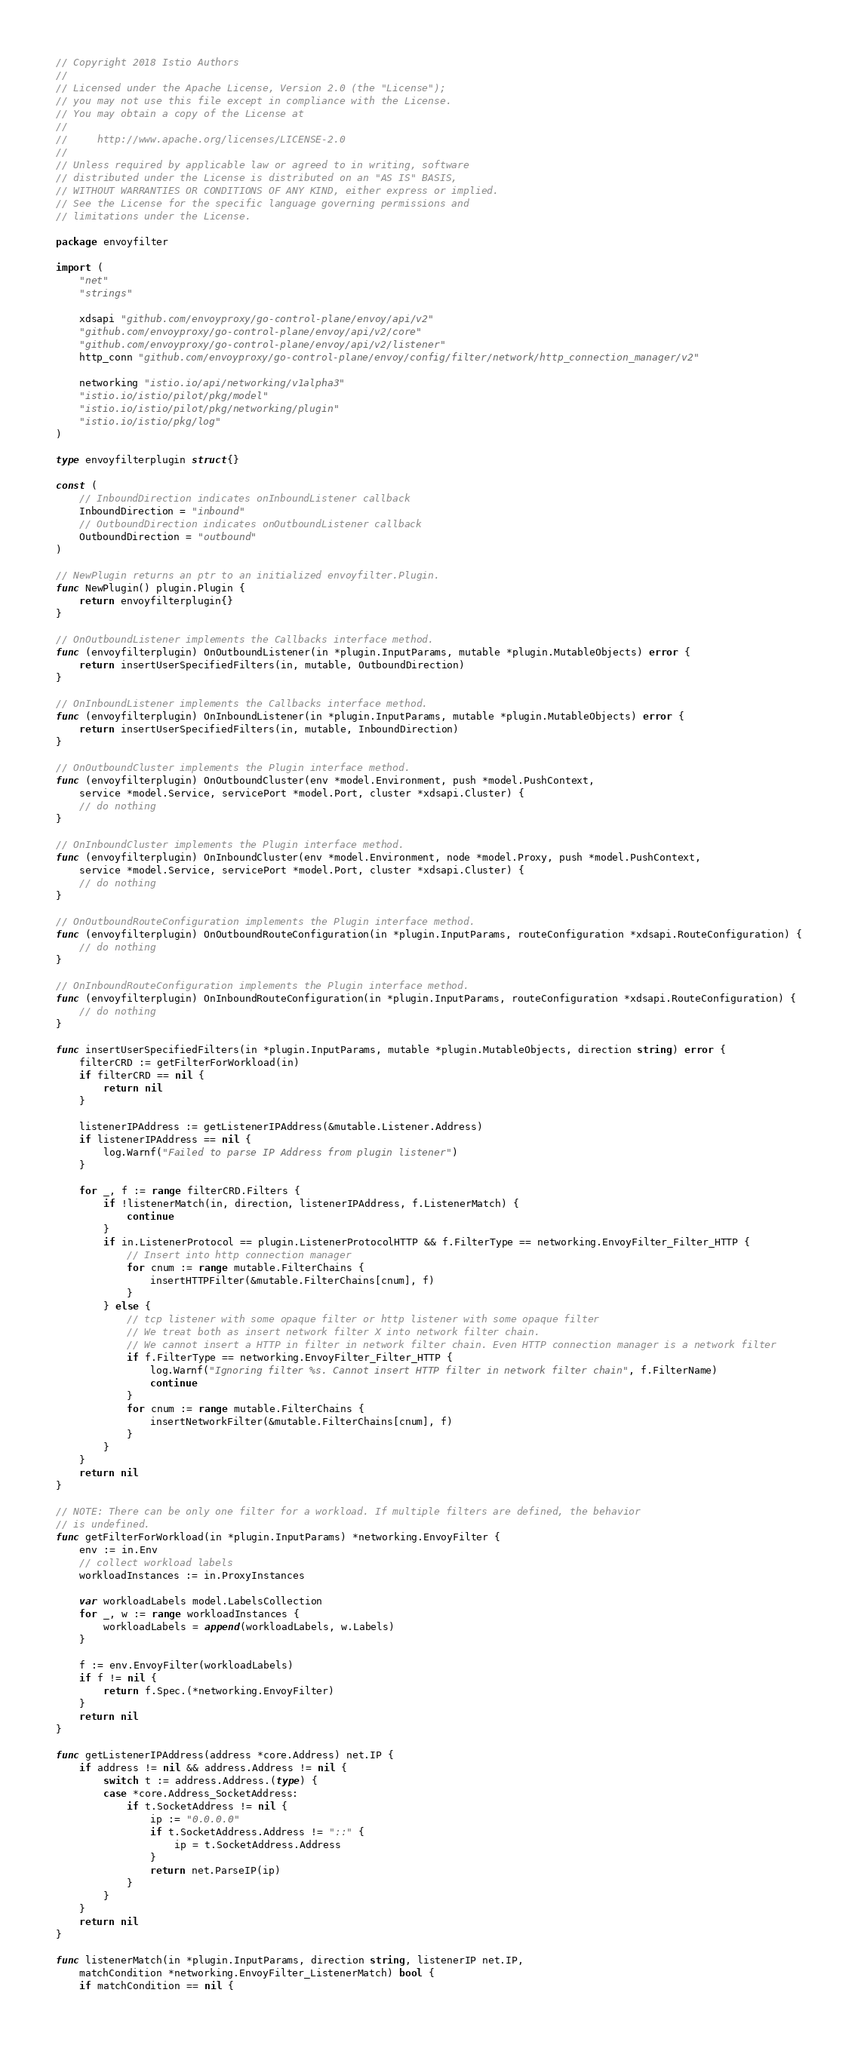<code> <loc_0><loc_0><loc_500><loc_500><_Go_>// Copyright 2018 Istio Authors
//
// Licensed under the Apache License, Version 2.0 (the "License");
// you may not use this file except in compliance with the License.
// You may obtain a copy of the License at
//
//     http://www.apache.org/licenses/LICENSE-2.0
//
// Unless required by applicable law or agreed to in writing, software
// distributed under the License is distributed on an "AS IS" BASIS,
// WITHOUT WARRANTIES OR CONDITIONS OF ANY KIND, either express or implied.
// See the License for the specific language governing permissions and
// limitations under the License.

package envoyfilter

import (
	"net"
	"strings"

	xdsapi "github.com/envoyproxy/go-control-plane/envoy/api/v2"
	"github.com/envoyproxy/go-control-plane/envoy/api/v2/core"
	"github.com/envoyproxy/go-control-plane/envoy/api/v2/listener"
	http_conn "github.com/envoyproxy/go-control-plane/envoy/config/filter/network/http_connection_manager/v2"

	networking "istio.io/api/networking/v1alpha3"
	"istio.io/istio/pilot/pkg/model"
	"istio.io/istio/pilot/pkg/networking/plugin"
	"istio.io/istio/pkg/log"
)

type envoyfilterplugin struct{}

const (
	// InboundDirection indicates onInboundListener callback
	InboundDirection = "inbound"
	// OutboundDirection indicates onOutboundListener callback
	OutboundDirection = "outbound"
)

// NewPlugin returns an ptr to an initialized envoyfilter.Plugin.
func NewPlugin() plugin.Plugin {
	return envoyfilterplugin{}
}

// OnOutboundListener implements the Callbacks interface method.
func (envoyfilterplugin) OnOutboundListener(in *plugin.InputParams, mutable *plugin.MutableObjects) error {
	return insertUserSpecifiedFilters(in, mutable, OutboundDirection)
}

// OnInboundListener implements the Callbacks interface method.
func (envoyfilterplugin) OnInboundListener(in *plugin.InputParams, mutable *plugin.MutableObjects) error {
	return insertUserSpecifiedFilters(in, mutable, InboundDirection)
}

// OnOutboundCluster implements the Plugin interface method.
func (envoyfilterplugin) OnOutboundCluster(env *model.Environment, push *model.PushContext,
	service *model.Service, servicePort *model.Port, cluster *xdsapi.Cluster) {
	// do nothing
}

// OnInboundCluster implements the Plugin interface method.
func (envoyfilterplugin) OnInboundCluster(env *model.Environment, node *model.Proxy, push *model.PushContext,
	service *model.Service, servicePort *model.Port, cluster *xdsapi.Cluster) {
	// do nothing
}

// OnOutboundRouteConfiguration implements the Plugin interface method.
func (envoyfilterplugin) OnOutboundRouteConfiguration(in *plugin.InputParams, routeConfiguration *xdsapi.RouteConfiguration) {
	// do nothing
}

// OnInboundRouteConfiguration implements the Plugin interface method.
func (envoyfilterplugin) OnInboundRouteConfiguration(in *plugin.InputParams, routeConfiguration *xdsapi.RouteConfiguration) {
	// do nothing
}

func insertUserSpecifiedFilters(in *plugin.InputParams, mutable *plugin.MutableObjects, direction string) error {
	filterCRD := getFilterForWorkload(in)
	if filterCRD == nil {
		return nil
	}

	listenerIPAddress := getListenerIPAddress(&mutable.Listener.Address)
	if listenerIPAddress == nil {
		log.Warnf("Failed to parse IP Address from plugin listener")
	}

	for _, f := range filterCRD.Filters {
		if !listenerMatch(in, direction, listenerIPAddress, f.ListenerMatch) {
			continue
		}
		if in.ListenerProtocol == plugin.ListenerProtocolHTTP && f.FilterType == networking.EnvoyFilter_Filter_HTTP {
			// Insert into http connection manager
			for cnum := range mutable.FilterChains {
				insertHTTPFilter(&mutable.FilterChains[cnum], f)
			}
		} else {
			// tcp listener with some opaque filter or http listener with some opaque filter
			// We treat both as insert network filter X into network filter chain.
			// We cannot insert a HTTP in filter in network filter chain. Even HTTP connection manager is a network filter
			if f.FilterType == networking.EnvoyFilter_Filter_HTTP {
				log.Warnf("Ignoring filter %s. Cannot insert HTTP filter in network filter chain", f.FilterName)
				continue
			}
			for cnum := range mutable.FilterChains {
				insertNetworkFilter(&mutable.FilterChains[cnum], f)
			}
		}
	}
	return nil
}

// NOTE: There can be only one filter for a workload. If multiple filters are defined, the behavior
// is undefined.
func getFilterForWorkload(in *plugin.InputParams) *networking.EnvoyFilter {
	env := in.Env
	// collect workload labels
	workloadInstances := in.ProxyInstances

	var workloadLabels model.LabelsCollection
	for _, w := range workloadInstances {
		workloadLabels = append(workloadLabels, w.Labels)
	}

	f := env.EnvoyFilter(workloadLabels)
	if f != nil {
		return f.Spec.(*networking.EnvoyFilter)
	}
	return nil
}

func getListenerIPAddress(address *core.Address) net.IP {
	if address != nil && address.Address != nil {
		switch t := address.Address.(type) {
		case *core.Address_SocketAddress:
			if t.SocketAddress != nil {
				ip := "0.0.0.0"
				if t.SocketAddress.Address != "::" {
					ip = t.SocketAddress.Address
				}
				return net.ParseIP(ip)
			}
		}
	}
	return nil
}

func listenerMatch(in *plugin.InputParams, direction string, listenerIP net.IP,
	matchCondition *networking.EnvoyFilter_ListenerMatch) bool {
	if matchCondition == nil {</code> 